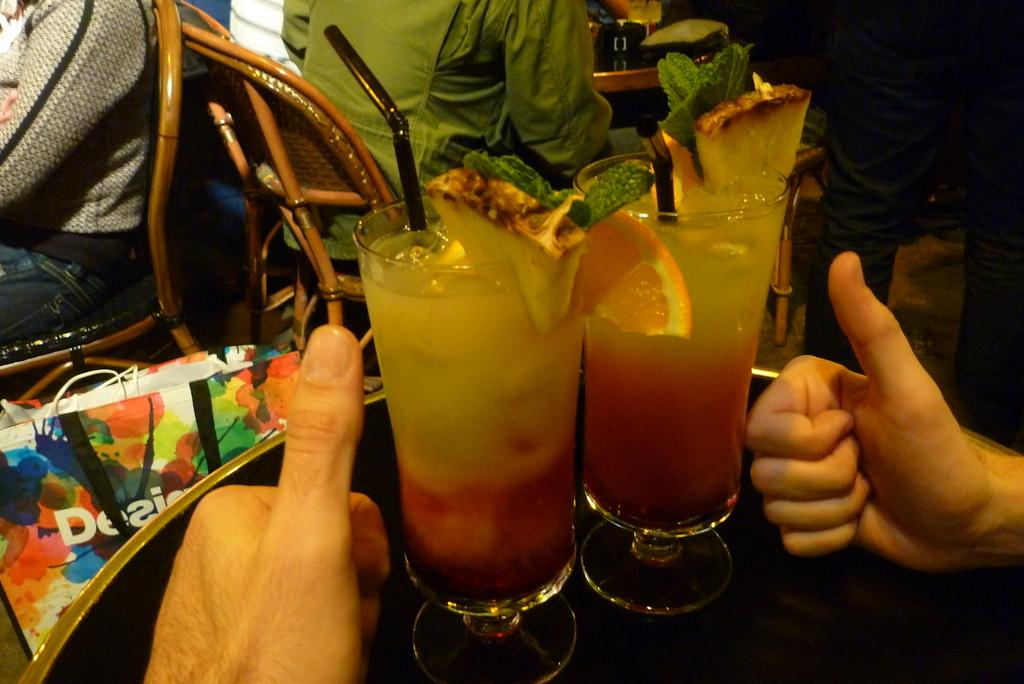Who or what is present in the image? There are people in the image. What objects can be seen on the table? There are glasses on a table. What is located beside the table? There is a bag beside the table. What is inside the glasses? There is a drink in the glasses. Who is the creator of the balls in the image? There are no balls present in the image, so it is not possible to determine who the creator might be. 